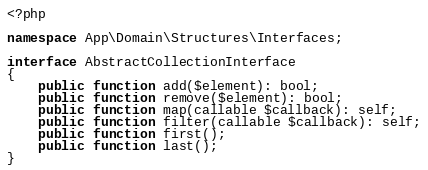<code> <loc_0><loc_0><loc_500><loc_500><_PHP_><?php

namespace App\Domain\Structures\Interfaces;

interface AbstractCollectionInterface
{
    public function add($element): bool;
    public function remove($element): bool;
    public function map(callable $callback): self;
    public function filter(callable $callback): self;
    public function first();
    public function last();
}
</code> 